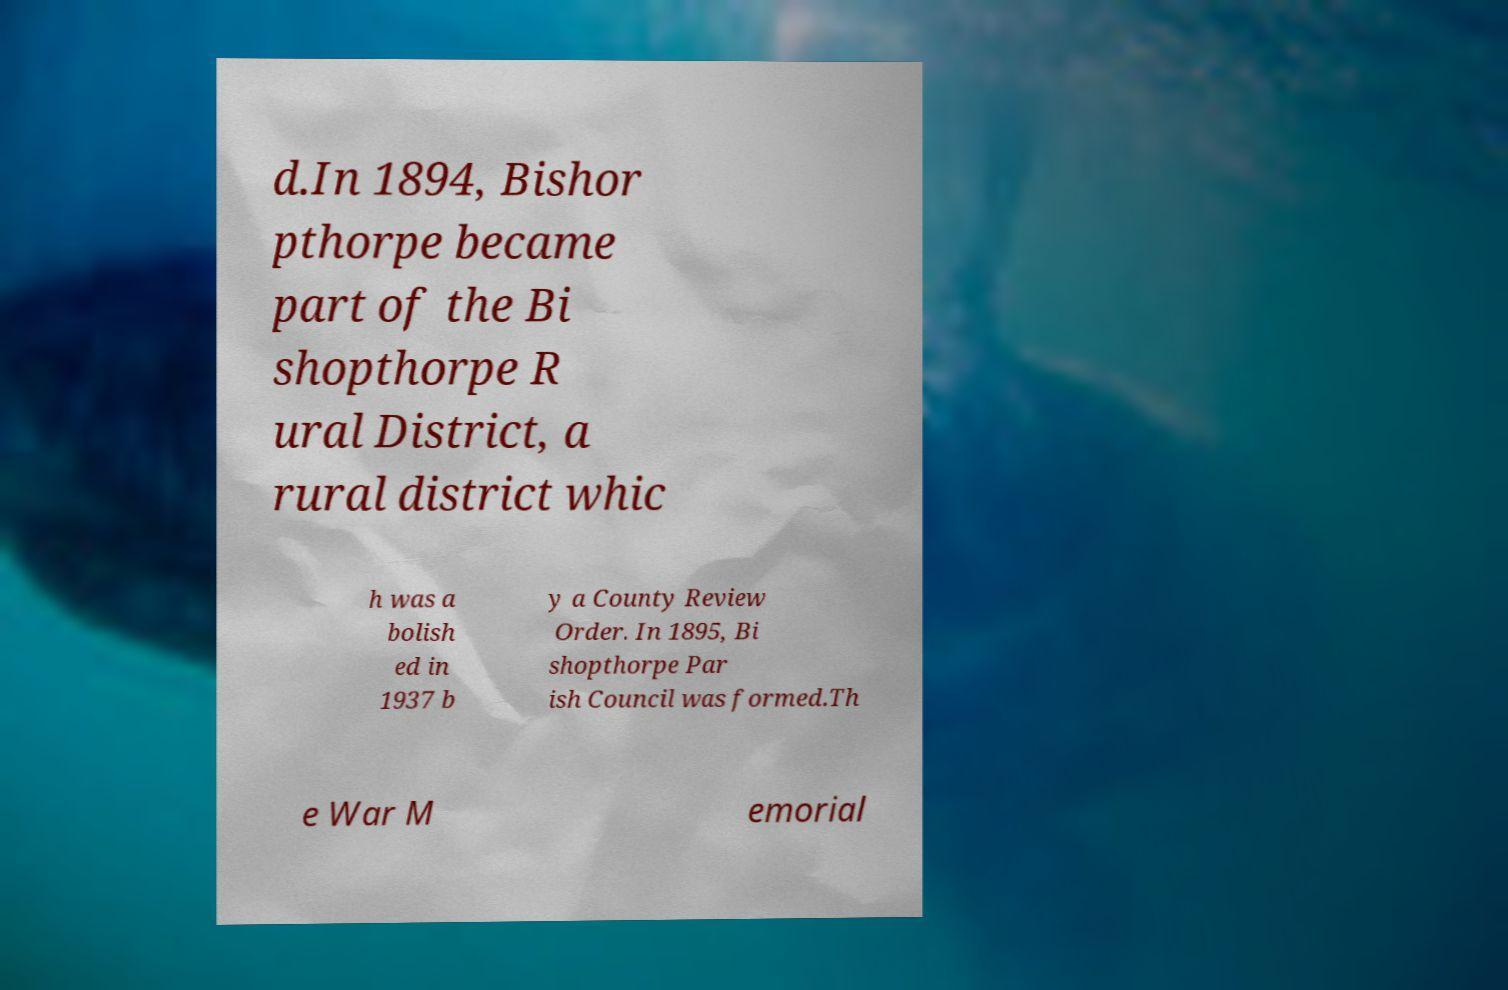For documentation purposes, I need the text within this image transcribed. Could you provide that? d.In 1894, Bishor pthorpe became part of the Bi shopthorpe R ural District, a rural district whic h was a bolish ed in 1937 b y a County Review Order. In 1895, Bi shopthorpe Par ish Council was formed.Th e War M emorial 